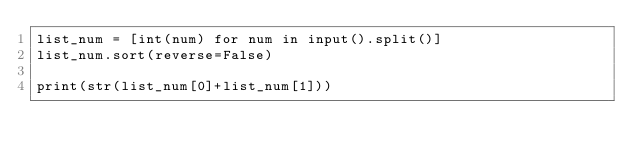Convert code to text. <code><loc_0><loc_0><loc_500><loc_500><_Python_>list_num = [int(num) for num in input().split()]
list_num.sort(reverse=False)

print(str(list_num[0]+list_num[1]))</code> 